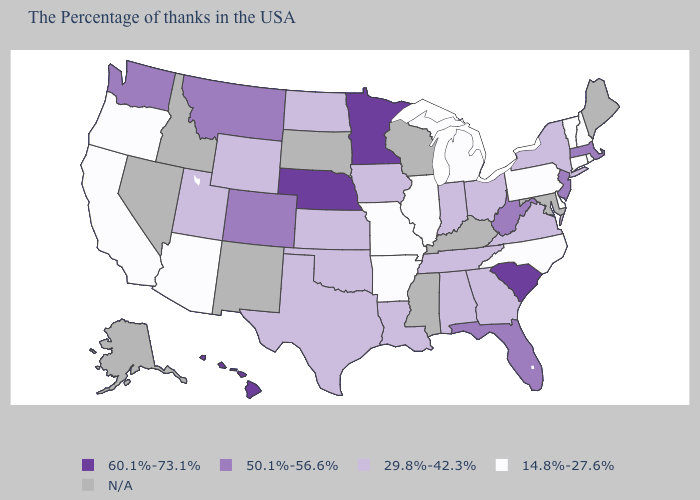What is the highest value in the USA?
Concise answer only. 60.1%-73.1%. What is the lowest value in the Northeast?
Write a very short answer. 14.8%-27.6%. Among the states that border New Jersey , does New York have the highest value?
Concise answer only. Yes. Name the states that have a value in the range 14.8%-27.6%?
Give a very brief answer. Rhode Island, New Hampshire, Vermont, Connecticut, Delaware, Pennsylvania, North Carolina, Michigan, Illinois, Missouri, Arkansas, Arizona, California, Oregon. Is the legend a continuous bar?
Answer briefly. No. How many symbols are there in the legend?
Keep it brief. 5. What is the value of California?
Keep it brief. 14.8%-27.6%. Which states hav the highest value in the MidWest?
Short answer required. Minnesota, Nebraska. Does California have the highest value in the USA?
Quick response, please. No. What is the lowest value in states that border Missouri?
Give a very brief answer. 14.8%-27.6%. What is the highest value in states that border Wisconsin?
Be succinct. 60.1%-73.1%. Which states hav the highest value in the MidWest?
Be succinct. Minnesota, Nebraska. Name the states that have a value in the range N/A?
Short answer required. Maine, Maryland, Kentucky, Wisconsin, Mississippi, South Dakota, New Mexico, Idaho, Nevada, Alaska. 